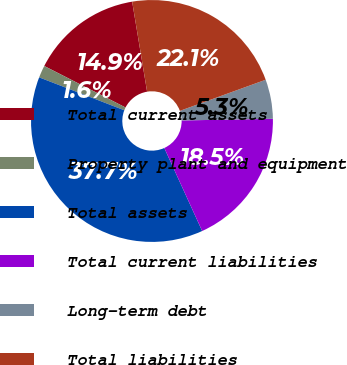Convert chart. <chart><loc_0><loc_0><loc_500><loc_500><pie_chart><fcel>Total current assets<fcel>Property plant and equipment<fcel>Total assets<fcel>Total current liabilities<fcel>Long-term debt<fcel>Total liabilities<nl><fcel>14.87%<fcel>1.64%<fcel>37.68%<fcel>18.47%<fcel>5.25%<fcel>22.08%<nl></chart> 